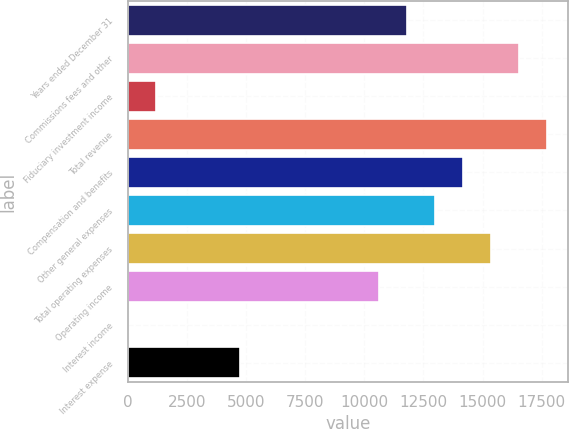Convert chart. <chart><loc_0><loc_0><loc_500><loc_500><bar_chart><fcel>Years ended December 31<fcel>Commissions fees and other<fcel>Fiduciary investment income<fcel>Total revenue<fcel>Compensation and benefits<fcel>Other general expenses<fcel>Total operating expenses<fcel>Operating income<fcel>Interest income<fcel>Interest expense<nl><fcel>11815<fcel>16537.4<fcel>1189.6<fcel>17718<fcel>14176.2<fcel>12995.6<fcel>15356.8<fcel>10634.4<fcel>9<fcel>4731.4<nl></chart> 